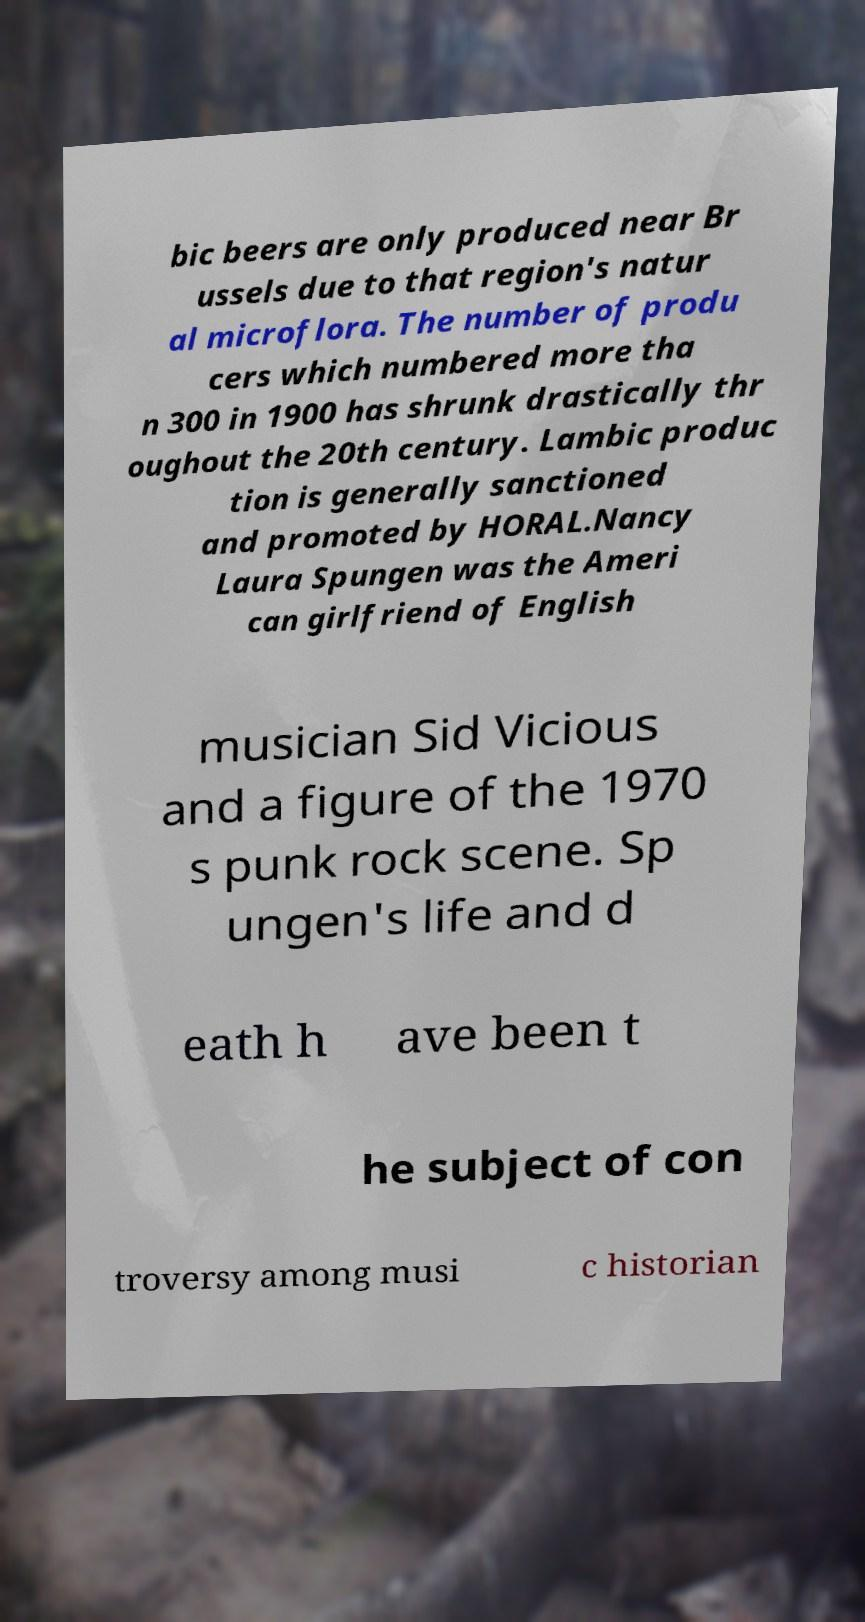I need the written content from this picture converted into text. Can you do that? bic beers are only produced near Br ussels due to that region's natur al microflora. The number of produ cers which numbered more tha n 300 in 1900 has shrunk drastically thr oughout the 20th century. Lambic produc tion is generally sanctioned and promoted by HORAL.Nancy Laura Spungen was the Ameri can girlfriend of English musician Sid Vicious and a figure of the 1970 s punk rock scene. Sp ungen's life and d eath h ave been t he subject of con troversy among musi c historian 